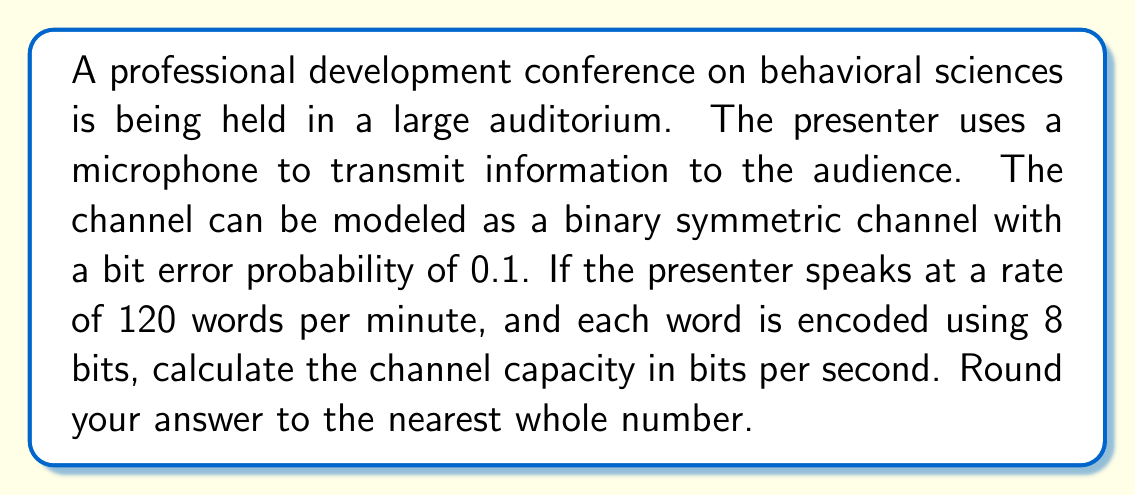Provide a solution to this math problem. To solve this problem, we need to follow these steps:

1. Calculate the input rate in bits per second:
   - Words per minute: 120
   - Bits per word: 8
   - Bits per minute: $120 \times 8 = 960$
   - Bits per second: $960 / 60 = 16$

2. Calculate the channel capacity using the formula for a binary symmetric channel:
   $$C = 1 - H(p)$$
   where $C$ is the channel capacity in bits per channel use, and $H(p)$ is the binary entropy function.

3. Calculate the binary entropy function:
   $$H(p) = -p \log_2(p) - (1-p) \log_2(1-p)$$
   where $p$ is the bit error probability (0.1 in this case).

   $$H(0.1) = -0.1 \log_2(0.1) - 0.9 \log_2(0.9)$$
   $$\approx 0.4690$$

4. Calculate the channel capacity per channel use:
   $$C = 1 - H(0.1) \approx 1 - 0.4690 \approx 0.5310$$

5. Calculate the total channel capacity in bits per second:
   Channel capacity (bits/s) = Input rate (bits/s) $\times$ Capacity per channel use
   $$16 \times 0.5310 \approx 8.4960$$

6. Round to the nearest whole number:
   $$8.4960 \approx 8$$
Answer: 8 bits per second 